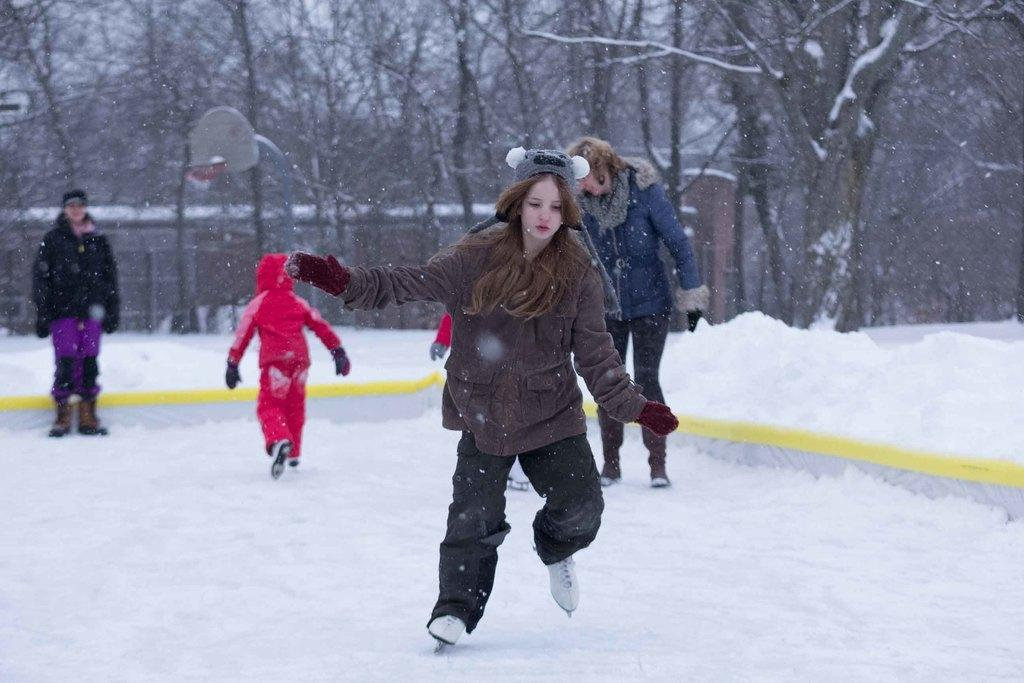Who is the main subject in the image? There is a girl in the image. What is the girl doing in the image? The girl is skating on the snow. Are there any other people in the image? Yes, there are people behind the girl. What can be seen in the background of the image? Trees covered with snow are visible behind the people. What other object is present in the image? There is a basketball pole in the image. What type of knot is being tied by the girl while skating in the image? There is no knot being tied by the girl in the image; she is skating on the snow. Can you see any branches on the trees in the image? The trees in the image are covered with snow, so it is not possible to see any branches. 